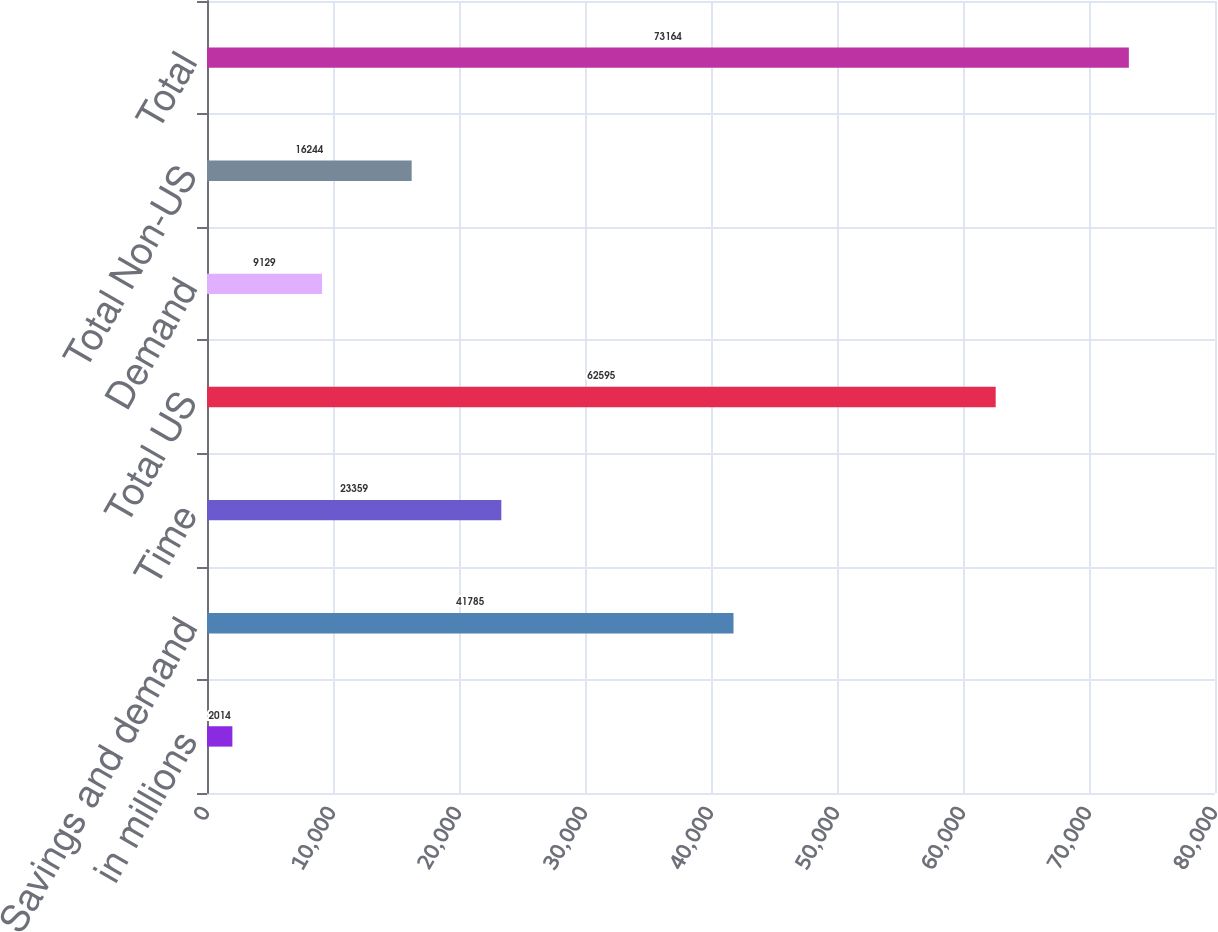Convert chart to OTSL. <chart><loc_0><loc_0><loc_500><loc_500><bar_chart><fcel>in millions<fcel>Savings and demand<fcel>Time<fcel>Total US<fcel>Demand<fcel>Total Non-US<fcel>Total<nl><fcel>2014<fcel>41785<fcel>23359<fcel>62595<fcel>9129<fcel>16244<fcel>73164<nl></chart> 